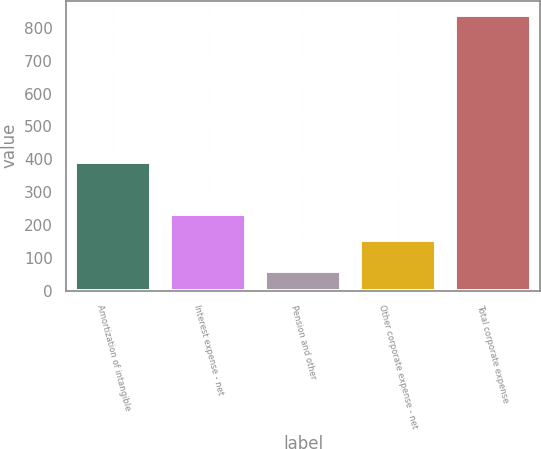Convert chart to OTSL. <chart><loc_0><loc_0><loc_500><loc_500><bar_chart><fcel>Amortization of intangible<fcel>Interest expense - net<fcel>Pension and other<fcel>Other corporate expense - net<fcel>Total corporate expense<nl><fcel>392<fcel>233<fcel>60<fcel>155<fcel>840<nl></chart> 